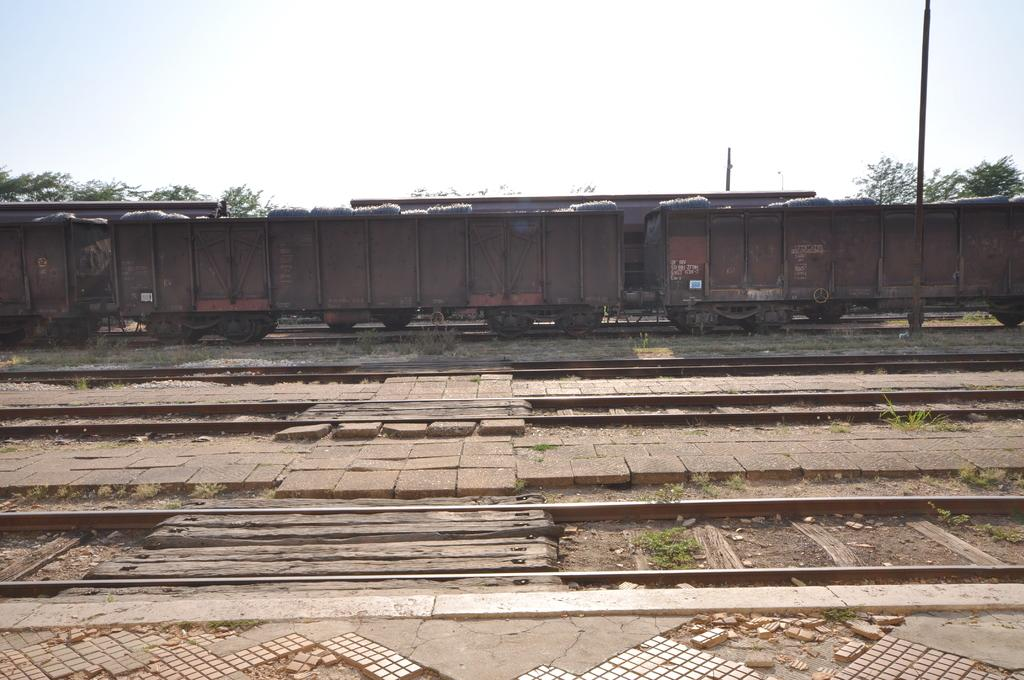What is the main subject of the image? There is a train in the image. What is the train positioned on? The train is on tracks. What can be seen beside the tracks? There are poles and trees beside the tracks. How many shelves are visible in the image? There are no shelves present in the image. What type of voyage is the train embarking on in the image? The image does not provide information about the train's voyage, so it cannot be determined from the picture. 